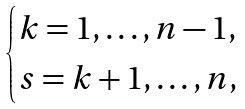Convert formula to latex. <formula><loc_0><loc_0><loc_500><loc_500>\begin{cases} k = 1 , \dots , n - 1 , \\ s = k + 1 , \dots , n , \end{cases}</formula> 